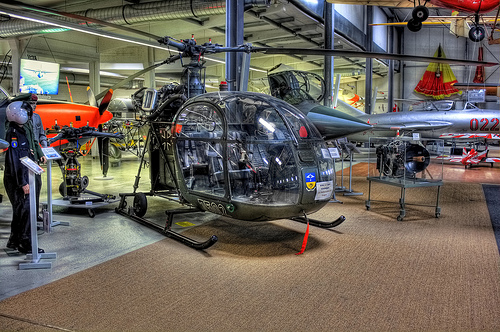<image>
Is there a helicopter above the floor? No. The helicopter is not positioned above the floor. The vertical arrangement shows a different relationship. 